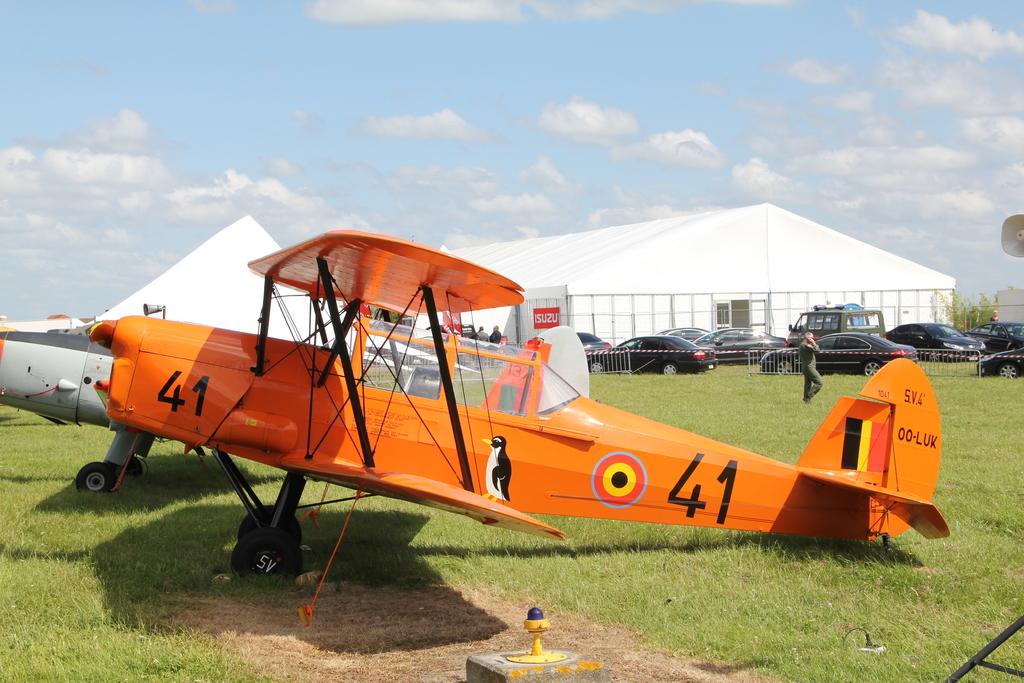What number is on the plane?
Offer a very short reply. 41. Is there any other text on the plane?
Ensure brevity in your answer.  Yes. 